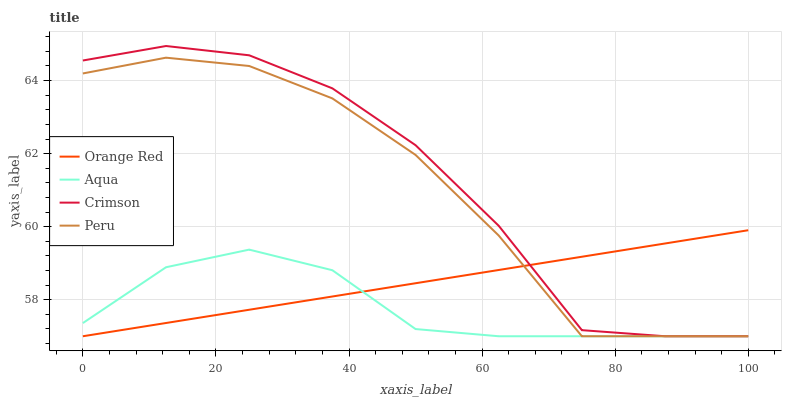Does Aqua have the minimum area under the curve?
Answer yes or no. Yes. Does Crimson have the maximum area under the curve?
Answer yes or no. Yes. Does Orange Red have the minimum area under the curve?
Answer yes or no. No. Does Orange Red have the maximum area under the curve?
Answer yes or no. No. Is Orange Red the smoothest?
Answer yes or no. Yes. Is Crimson the roughest?
Answer yes or no. Yes. Is Aqua the smoothest?
Answer yes or no. No. Is Aqua the roughest?
Answer yes or no. No. Does Orange Red have the highest value?
Answer yes or no. No. 